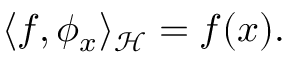Convert formula to latex. <formula><loc_0><loc_0><loc_500><loc_500>\langle f , \phi _ { x } \rangle _ { \mathcal { H } } = f ( x ) .</formula> 